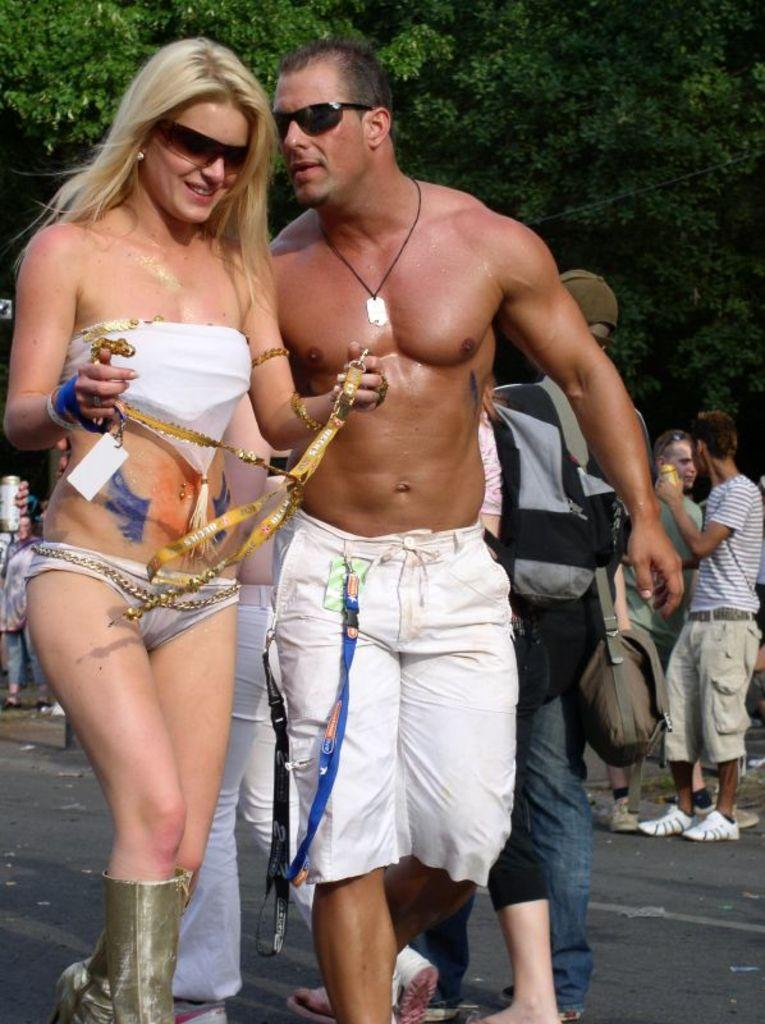Who can be seen in the image? There is a man and a woman in the image. What are the man and woman doing in the image? Both the man and woman are walking along a road. What can be seen in the background of the image? There are people standing in the background of the image, and there are trees visible as well. What page of the book is the father reading to his friends in the image? There is no book or father present in the image; it features a man and a woman walking along a road. 